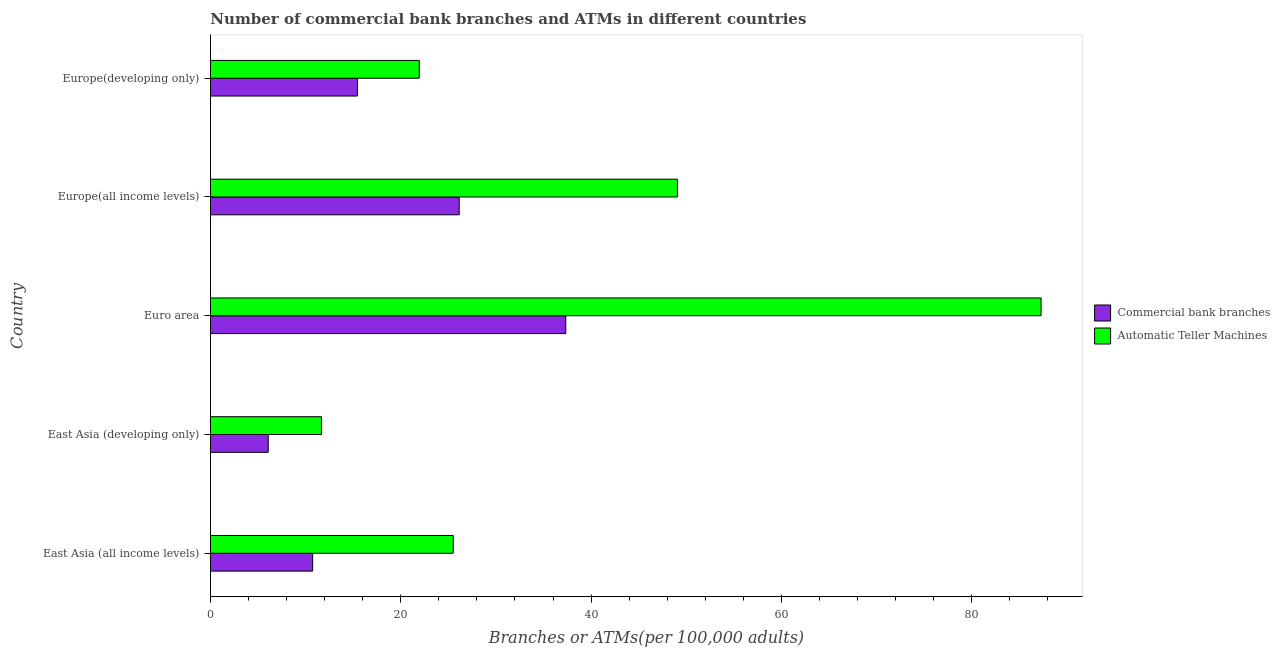How many groups of bars are there?
Provide a short and direct response. 5. Are the number of bars per tick equal to the number of legend labels?
Keep it short and to the point. Yes. Are the number of bars on each tick of the Y-axis equal?
Your answer should be very brief. Yes. What is the label of the 1st group of bars from the top?
Offer a very short reply. Europe(developing only). What is the number of atms in Europe(developing only)?
Your response must be concise. 21.94. Across all countries, what is the maximum number of atms?
Keep it short and to the point. 87.29. Across all countries, what is the minimum number of atms?
Your response must be concise. 11.66. In which country was the number of atms maximum?
Offer a very short reply. Euro area. In which country was the number of atms minimum?
Offer a very short reply. East Asia (developing only). What is the total number of commercal bank branches in the graph?
Your answer should be compact. 95.74. What is the difference between the number of atms in Euro area and that in Europe(developing only)?
Give a very brief answer. 65.35. What is the difference between the number of atms in Europe(developing only) and the number of commercal bank branches in East Asia (all income levels)?
Your answer should be compact. 11.2. What is the average number of commercal bank branches per country?
Ensure brevity in your answer.  19.15. What is the difference between the number of atms and number of commercal bank branches in East Asia (developing only)?
Your answer should be very brief. 5.59. What is the ratio of the number of commercal bank branches in Euro area to that in Europe(developing only)?
Your answer should be compact. 2.42. Is the number of atms in East Asia (all income levels) less than that in East Asia (developing only)?
Offer a terse response. No. Is the difference between the number of atms in Euro area and Europe(developing only) greater than the difference between the number of commercal bank branches in Euro area and Europe(developing only)?
Offer a terse response. Yes. What is the difference between the highest and the second highest number of atms?
Your answer should be very brief. 38.22. What is the difference between the highest and the lowest number of commercal bank branches?
Provide a short and direct response. 31.27. What does the 2nd bar from the top in East Asia (all income levels) represents?
Your response must be concise. Commercial bank branches. What does the 1st bar from the bottom in East Asia (all income levels) represents?
Offer a very short reply. Commercial bank branches. Are all the bars in the graph horizontal?
Make the answer very short. Yes. Are the values on the major ticks of X-axis written in scientific E-notation?
Give a very brief answer. No. Does the graph contain any zero values?
Your answer should be very brief. No. Does the graph contain grids?
Offer a terse response. No. Where does the legend appear in the graph?
Your answer should be compact. Center right. How many legend labels are there?
Give a very brief answer. 2. What is the title of the graph?
Provide a succinct answer. Number of commercial bank branches and ATMs in different countries. What is the label or title of the X-axis?
Give a very brief answer. Branches or ATMs(per 100,0 adults). What is the label or title of the Y-axis?
Provide a short and direct response. Country. What is the Branches or ATMs(per 100,000 adults) of Commercial bank branches in East Asia (all income levels)?
Your answer should be very brief. 10.74. What is the Branches or ATMs(per 100,000 adults) in Automatic Teller Machines in East Asia (all income levels)?
Keep it short and to the point. 25.51. What is the Branches or ATMs(per 100,000 adults) in Commercial bank branches in East Asia (developing only)?
Your answer should be very brief. 6.07. What is the Branches or ATMs(per 100,000 adults) in Automatic Teller Machines in East Asia (developing only)?
Make the answer very short. 11.66. What is the Branches or ATMs(per 100,000 adults) in Commercial bank branches in Euro area?
Provide a short and direct response. 37.34. What is the Branches or ATMs(per 100,000 adults) of Automatic Teller Machines in Euro area?
Your answer should be compact. 87.29. What is the Branches or ATMs(per 100,000 adults) of Commercial bank branches in Europe(all income levels)?
Offer a very short reply. 26.14. What is the Branches or ATMs(per 100,000 adults) of Automatic Teller Machines in Europe(all income levels)?
Your answer should be very brief. 49.07. What is the Branches or ATMs(per 100,000 adults) in Commercial bank branches in Europe(developing only)?
Provide a short and direct response. 15.45. What is the Branches or ATMs(per 100,000 adults) in Automatic Teller Machines in Europe(developing only)?
Offer a very short reply. 21.94. Across all countries, what is the maximum Branches or ATMs(per 100,000 adults) in Commercial bank branches?
Your answer should be very brief. 37.34. Across all countries, what is the maximum Branches or ATMs(per 100,000 adults) of Automatic Teller Machines?
Your answer should be compact. 87.29. Across all countries, what is the minimum Branches or ATMs(per 100,000 adults) of Commercial bank branches?
Provide a short and direct response. 6.07. Across all countries, what is the minimum Branches or ATMs(per 100,000 adults) of Automatic Teller Machines?
Your answer should be compact. 11.66. What is the total Branches or ATMs(per 100,000 adults) of Commercial bank branches in the graph?
Offer a very short reply. 95.74. What is the total Branches or ATMs(per 100,000 adults) of Automatic Teller Machines in the graph?
Provide a short and direct response. 195.48. What is the difference between the Branches or ATMs(per 100,000 adults) of Commercial bank branches in East Asia (all income levels) and that in East Asia (developing only)?
Give a very brief answer. 4.67. What is the difference between the Branches or ATMs(per 100,000 adults) of Automatic Teller Machines in East Asia (all income levels) and that in East Asia (developing only)?
Give a very brief answer. 13.85. What is the difference between the Branches or ATMs(per 100,000 adults) of Commercial bank branches in East Asia (all income levels) and that in Euro area?
Provide a short and direct response. -26.6. What is the difference between the Branches or ATMs(per 100,000 adults) in Automatic Teller Machines in East Asia (all income levels) and that in Euro area?
Provide a short and direct response. -61.78. What is the difference between the Branches or ATMs(per 100,000 adults) of Commercial bank branches in East Asia (all income levels) and that in Europe(all income levels)?
Provide a succinct answer. -15.4. What is the difference between the Branches or ATMs(per 100,000 adults) of Automatic Teller Machines in East Asia (all income levels) and that in Europe(all income levels)?
Your answer should be very brief. -23.56. What is the difference between the Branches or ATMs(per 100,000 adults) in Commercial bank branches in East Asia (all income levels) and that in Europe(developing only)?
Ensure brevity in your answer.  -4.71. What is the difference between the Branches or ATMs(per 100,000 adults) of Automatic Teller Machines in East Asia (all income levels) and that in Europe(developing only)?
Offer a very short reply. 3.57. What is the difference between the Branches or ATMs(per 100,000 adults) of Commercial bank branches in East Asia (developing only) and that in Euro area?
Offer a terse response. -31.27. What is the difference between the Branches or ATMs(per 100,000 adults) in Automatic Teller Machines in East Asia (developing only) and that in Euro area?
Ensure brevity in your answer.  -75.63. What is the difference between the Branches or ATMs(per 100,000 adults) of Commercial bank branches in East Asia (developing only) and that in Europe(all income levels)?
Offer a terse response. -20.07. What is the difference between the Branches or ATMs(per 100,000 adults) in Automatic Teller Machines in East Asia (developing only) and that in Europe(all income levels)?
Ensure brevity in your answer.  -37.41. What is the difference between the Branches or ATMs(per 100,000 adults) in Commercial bank branches in East Asia (developing only) and that in Europe(developing only)?
Make the answer very short. -9.38. What is the difference between the Branches or ATMs(per 100,000 adults) in Automatic Teller Machines in East Asia (developing only) and that in Europe(developing only)?
Offer a terse response. -10.28. What is the difference between the Branches or ATMs(per 100,000 adults) in Commercial bank branches in Euro area and that in Europe(all income levels)?
Provide a short and direct response. 11.2. What is the difference between the Branches or ATMs(per 100,000 adults) in Automatic Teller Machines in Euro area and that in Europe(all income levels)?
Your answer should be very brief. 38.22. What is the difference between the Branches or ATMs(per 100,000 adults) of Commercial bank branches in Euro area and that in Europe(developing only)?
Ensure brevity in your answer.  21.89. What is the difference between the Branches or ATMs(per 100,000 adults) of Automatic Teller Machines in Euro area and that in Europe(developing only)?
Keep it short and to the point. 65.35. What is the difference between the Branches or ATMs(per 100,000 adults) in Commercial bank branches in Europe(all income levels) and that in Europe(developing only)?
Ensure brevity in your answer.  10.69. What is the difference between the Branches or ATMs(per 100,000 adults) of Automatic Teller Machines in Europe(all income levels) and that in Europe(developing only)?
Your answer should be compact. 27.13. What is the difference between the Branches or ATMs(per 100,000 adults) of Commercial bank branches in East Asia (all income levels) and the Branches or ATMs(per 100,000 adults) of Automatic Teller Machines in East Asia (developing only)?
Offer a very short reply. -0.93. What is the difference between the Branches or ATMs(per 100,000 adults) in Commercial bank branches in East Asia (all income levels) and the Branches or ATMs(per 100,000 adults) in Automatic Teller Machines in Euro area?
Provide a succinct answer. -76.55. What is the difference between the Branches or ATMs(per 100,000 adults) in Commercial bank branches in East Asia (all income levels) and the Branches or ATMs(per 100,000 adults) in Automatic Teller Machines in Europe(all income levels)?
Offer a terse response. -38.34. What is the difference between the Branches or ATMs(per 100,000 adults) in Commercial bank branches in East Asia (all income levels) and the Branches or ATMs(per 100,000 adults) in Automatic Teller Machines in Europe(developing only)?
Your answer should be very brief. -11.2. What is the difference between the Branches or ATMs(per 100,000 adults) in Commercial bank branches in East Asia (developing only) and the Branches or ATMs(per 100,000 adults) in Automatic Teller Machines in Euro area?
Offer a terse response. -81.22. What is the difference between the Branches or ATMs(per 100,000 adults) in Commercial bank branches in East Asia (developing only) and the Branches or ATMs(per 100,000 adults) in Automatic Teller Machines in Europe(all income levels)?
Provide a succinct answer. -43. What is the difference between the Branches or ATMs(per 100,000 adults) of Commercial bank branches in East Asia (developing only) and the Branches or ATMs(per 100,000 adults) of Automatic Teller Machines in Europe(developing only)?
Provide a short and direct response. -15.87. What is the difference between the Branches or ATMs(per 100,000 adults) in Commercial bank branches in Euro area and the Branches or ATMs(per 100,000 adults) in Automatic Teller Machines in Europe(all income levels)?
Your response must be concise. -11.74. What is the difference between the Branches or ATMs(per 100,000 adults) of Commercial bank branches in Euro area and the Branches or ATMs(per 100,000 adults) of Automatic Teller Machines in Europe(developing only)?
Your answer should be compact. 15.4. What is the difference between the Branches or ATMs(per 100,000 adults) of Commercial bank branches in Europe(all income levels) and the Branches or ATMs(per 100,000 adults) of Automatic Teller Machines in Europe(developing only)?
Keep it short and to the point. 4.2. What is the average Branches or ATMs(per 100,000 adults) of Commercial bank branches per country?
Provide a short and direct response. 19.15. What is the average Branches or ATMs(per 100,000 adults) in Automatic Teller Machines per country?
Provide a short and direct response. 39.1. What is the difference between the Branches or ATMs(per 100,000 adults) of Commercial bank branches and Branches or ATMs(per 100,000 adults) of Automatic Teller Machines in East Asia (all income levels)?
Give a very brief answer. -14.78. What is the difference between the Branches or ATMs(per 100,000 adults) of Commercial bank branches and Branches or ATMs(per 100,000 adults) of Automatic Teller Machines in East Asia (developing only)?
Provide a succinct answer. -5.59. What is the difference between the Branches or ATMs(per 100,000 adults) in Commercial bank branches and Branches or ATMs(per 100,000 adults) in Automatic Teller Machines in Euro area?
Keep it short and to the point. -49.95. What is the difference between the Branches or ATMs(per 100,000 adults) of Commercial bank branches and Branches or ATMs(per 100,000 adults) of Automatic Teller Machines in Europe(all income levels)?
Provide a succinct answer. -22.93. What is the difference between the Branches or ATMs(per 100,000 adults) of Commercial bank branches and Branches or ATMs(per 100,000 adults) of Automatic Teller Machines in Europe(developing only)?
Your answer should be very brief. -6.49. What is the ratio of the Branches or ATMs(per 100,000 adults) in Commercial bank branches in East Asia (all income levels) to that in East Asia (developing only)?
Offer a very short reply. 1.77. What is the ratio of the Branches or ATMs(per 100,000 adults) of Automatic Teller Machines in East Asia (all income levels) to that in East Asia (developing only)?
Ensure brevity in your answer.  2.19. What is the ratio of the Branches or ATMs(per 100,000 adults) of Commercial bank branches in East Asia (all income levels) to that in Euro area?
Your answer should be very brief. 0.29. What is the ratio of the Branches or ATMs(per 100,000 adults) in Automatic Teller Machines in East Asia (all income levels) to that in Euro area?
Your response must be concise. 0.29. What is the ratio of the Branches or ATMs(per 100,000 adults) in Commercial bank branches in East Asia (all income levels) to that in Europe(all income levels)?
Ensure brevity in your answer.  0.41. What is the ratio of the Branches or ATMs(per 100,000 adults) of Automatic Teller Machines in East Asia (all income levels) to that in Europe(all income levels)?
Make the answer very short. 0.52. What is the ratio of the Branches or ATMs(per 100,000 adults) of Commercial bank branches in East Asia (all income levels) to that in Europe(developing only)?
Provide a short and direct response. 0.69. What is the ratio of the Branches or ATMs(per 100,000 adults) of Automatic Teller Machines in East Asia (all income levels) to that in Europe(developing only)?
Your answer should be very brief. 1.16. What is the ratio of the Branches or ATMs(per 100,000 adults) in Commercial bank branches in East Asia (developing only) to that in Euro area?
Make the answer very short. 0.16. What is the ratio of the Branches or ATMs(per 100,000 adults) in Automatic Teller Machines in East Asia (developing only) to that in Euro area?
Offer a very short reply. 0.13. What is the ratio of the Branches or ATMs(per 100,000 adults) of Commercial bank branches in East Asia (developing only) to that in Europe(all income levels)?
Keep it short and to the point. 0.23. What is the ratio of the Branches or ATMs(per 100,000 adults) in Automatic Teller Machines in East Asia (developing only) to that in Europe(all income levels)?
Provide a short and direct response. 0.24. What is the ratio of the Branches or ATMs(per 100,000 adults) of Commercial bank branches in East Asia (developing only) to that in Europe(developing only)?
Ensure brevity in your answer.  0.39. What is the ratio of the Branches or ATMs(per 100,000 adults) of Automatic Teller Machines in East Asia (developing only) to that in Europe(developing only)?
Keep it short and to the point. 0.53. What is the ratio of the Branches or ATMs(per 100,000 adults) of Commercial bank branches in Euro area to that in Europe(all income levels)?
Your answer should be very brief. 1.43. What is the ratio of the Branches or ATMs(per 100,000 adults) in Automatic Teller Machines in Euro area to that in Europe(all income levels)?
Provide a short and direct response. 1.78. What is the ratio of the Branches or ATMs(per 100,000 adults) in Commercial bank branches in Euro area to that in Europe(developing only)?
Make the answer very short. 2.42. What is the ratio of the Branches or ATMs(per 100,000 adults) of Automatic Teller Machines in Euro area to that in Europe(developing only)?
Provide a short and direct response. 3.98. What is the ratio of the Branches or ATMs(per 100,000 adults) of Commercial bank branches in Europe(all income levels) to that in Europe(developing only)?
Provide a succinct answer. 1.69. What is the ratio of the Branches or ATMs(per 100,000 adults) in Automatic Teller Machines in Europe(all income levels) to that in Europe(developing only)?
Your answer should be very brief. 2.24. What is the difference between the highest and the second highest Branches or ATMs(per 100,000 adults) of Commercial bank branches?
Offer a terse response. 11.2. What is the difference between the highest and the second highest Branches or ATMs(per 100,000 adults) in Automatic Teller Machines?
Ensure brevity in your answer.  38.22. What is the difference between the highest and the lowest Branches or ATMs(per 100,000 adults) in Commercial bank branches?
Provide a short and direct response. 31.27. What is the difference between the highest and the lowest Branches or ATMs(per 100,000 adults) of Automatic Teller Machines?
Ensure brevity in your answer.  75.63. 